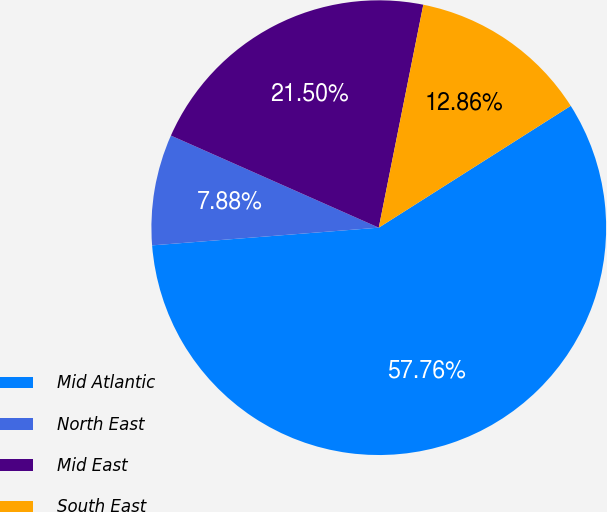<chart> <loc_0><loc_0><loc_500><loc_500><pie_chart><fcel>Mid Atlantic<fcel>North East<fcel>Mid East<fcel>South East<nl><fcel>57.76%<fcel>7.88%<fcel>21.5%<fcel>12.86%<nl></chart> 